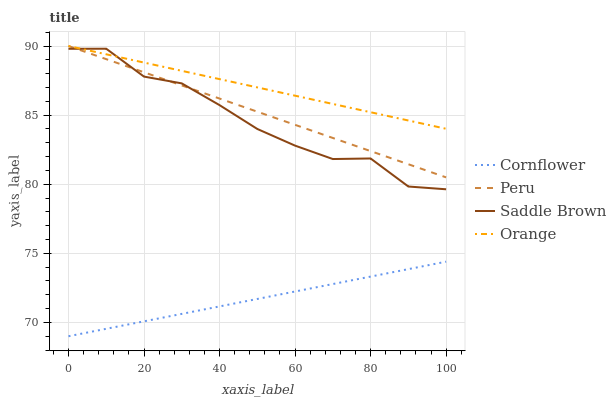Does Cornflower have the minimum area under the curve?
Answer yes or no. Yes. Does Orange have the maximum area under the curve?
Answer yes or no. Yes. Does Saddle Brown have the minimum area under the curve?
Answer yes or no. No. Does Saddle Brown have the maximum area under the curve?
Answer yes or no. No. Is Peru the smoothest?
Answer yes or no. Yes. Is Saddle Brown the roughest?
Answer yes or no. Yes. Is Cornflower the smoothest?
Answer yes or no. No. Is Cornflower the roughest?
Answer yes or no. No. Does Cornflower have the lowest value?
Answer yes or no. Yes. Does Saddle Brown have the lowest value?
Answer yes or no. No. Does Peru have the highest value?
Answer yes or no. Yes. Does Saddle Brown have the highest value?
Answer yes or no. No. Is Cornflower less than Orange?
Answer yes or no. Yes. Is Saddle Brown greater than Cornflower?
Answer yes or no. Yes. Does Peru intersect Saddle Brown?
Answer yes or no. Yes. Is Peru less than Saddle Brown?
Answer yes or no. No. Is Peru greater than Saddle Brown?
Answer yes or no. No. Does Cornflower intersect Orange?
Answer yes or no. No. 